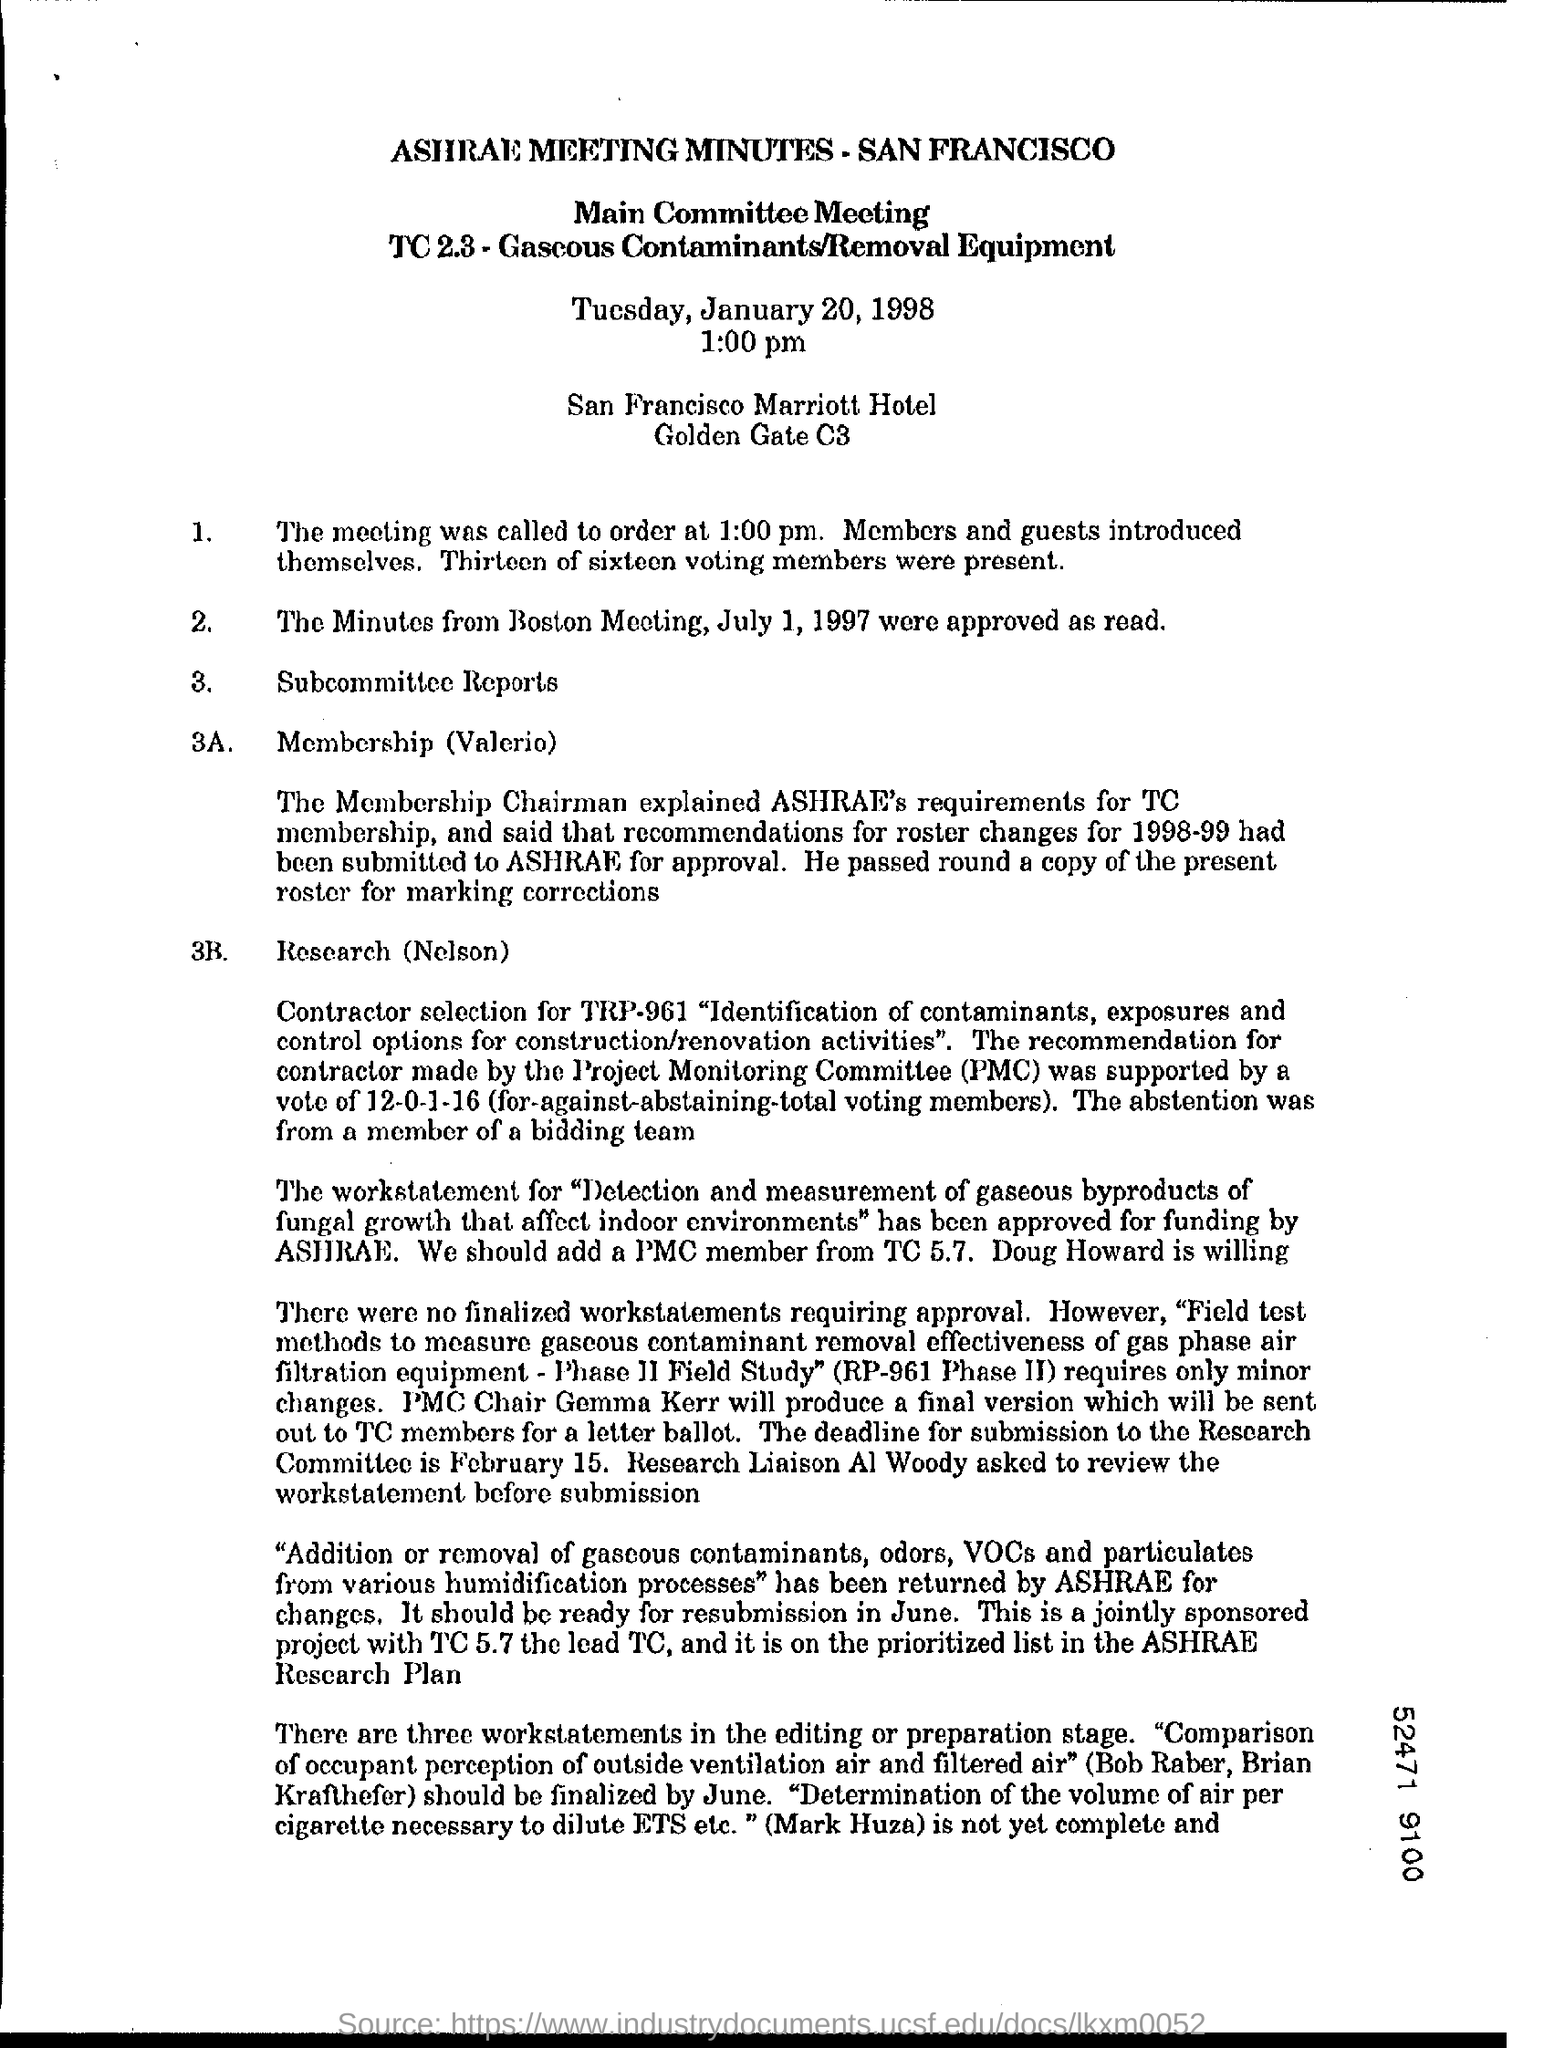Specify some key components in this picture. I approve the minutes from July 1, 1997. The time mentioned in this document is 1.00 pm. I introduced myself and the guests to the group. The Membership Chairman explained the requirements. 